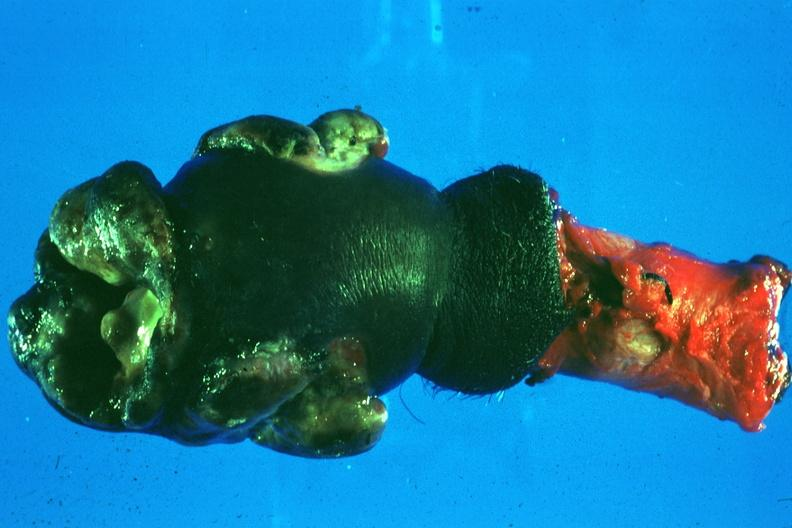s penis present?
Answer the question using a single word or phrase. Yes 